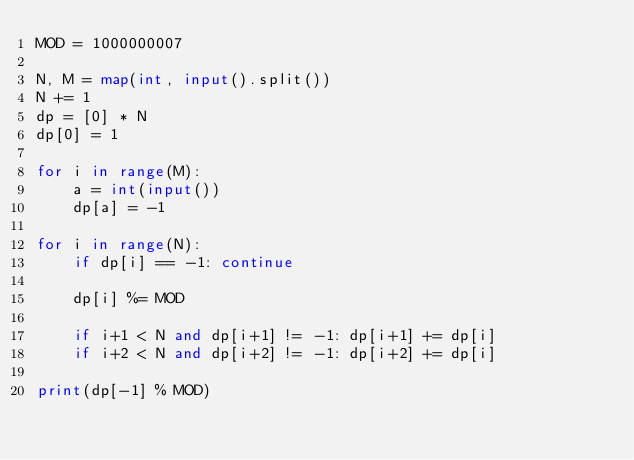Convert code to text. <code><loc_0><loc_0><loc_500><loc_500><_Python_>MOD = 1000000007

N, M = map(int, input().split())
N += 1
dp = [0] * N
dp[0] = 1

for i in range(M):
    a = int(input())
    dp[a] = -1
    
for i in range(N):
    if dp[i] == -1: continue

    dp[i] %= MOD
    
    if i+1 < N and dp[i+1] != -1: dp[i+1] += dp[i]
    if i+2 < N and dp[i+2] != -1: dp[i+2] += dp[i]

print(dp[-1] % MOD)
</code> 